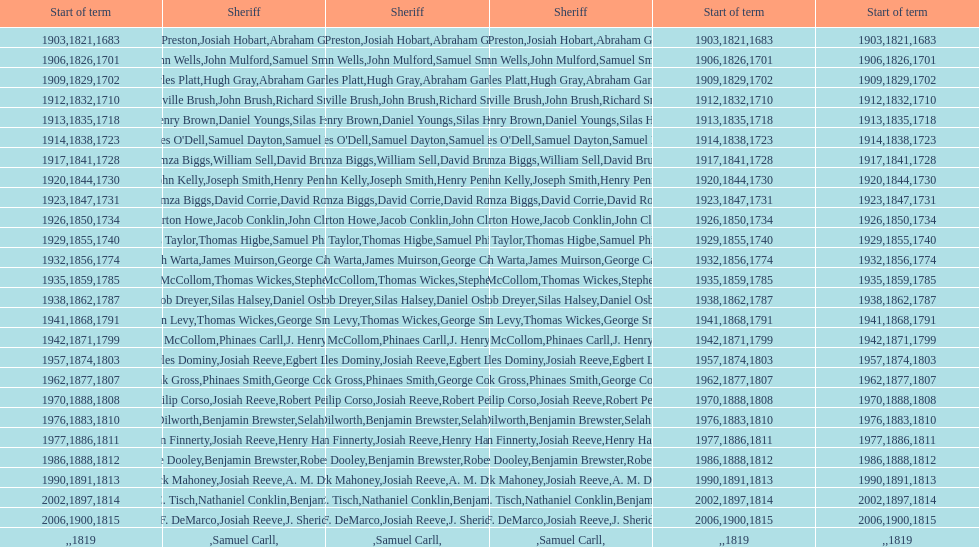Could you help me parse every detail presented in this table? {'header': ['Start of term', 'Sheriff', 'Sheriff', 'Sheriff', 'Start of term', 'Start of term'], 'rows': [['1903', 'Henry Preston', 'Josiah Hobart', 'Abraham Gardiner', '1821', '1683'], ['1906', 'John Wells', 'John Mulford', 'Samuel Smith', '1826', '1701'], ['1909', 'Charles Platt', 'Hugh Gray', 'Abraham Gardiner', '1829', '1702'], ['1912', 'Melville Brush', 'John Brush', 'Richard Smith', '1832', '1710'], ['1913', 'D. Henry Brown', 'Daniel Youngs', 'Silas Horton', '1835', '1718'], ['1914', "Charles O'Dell", 'Samuel Dayton', 'Samuel Miller', '1838', '1723'], ['1917', 'Amza Biggs', 'William Sell', 'David Brush', '1841', '1728'], ['1920', 'John Kelly', 'Joseph Smith', 'Henry Penny', '1844', '1730'], ['1923', 'Amza Biggs', 'David Corrie', 'David Rose', '1847', '1731'], ['1926', 'Burton Howe', 'Jacob Conklin', 'John Clark', '1850', '1734'], ['1929', 'Ellis Taylor', 'Thomas Higbe', 'Samuel Phillips', '1855', '1740'], ['1932', 'Joseph Warta', 'James Muirson', 'George Carman', '1856', '1774'], ['1935', 'William McCollom', 'Thomas Wickes', 'Stephen Wilson', '1859', '1785'], ['1938', 'Jacob Dreyer', 'Silas Halsey', 'Daniel Osborn', '1862', '1787'], ['1941', 'John Levy', 'Thomas Wickes', 'George Smith', '1868', '1791'], ['1942', 'William McCollom', 'Phinaes Carll', 'J. Henry Perkins', '1871', '1799'], ['1957', 'Charles Dominy', 'Josiah Reeve', 'Egbert Lewis', '1874', '1803'], ['1962', 'Frank Gross', 'Phinaes Smith', 'George Cooper', '1877', '1807'], ['1970', 'Philip Corso', 'Josiah Reeve', 'Robert Petty', '1888', '1808'], ['1976', 'Donald Dilworth', 'Benjamin Brewster', 'Selah Brewster', '1883', '1810'], ['1977', 'John Finnerty', 'Josiah Reeve', 'Henry Halsey', '1886', '1811'], ['1986', 'Eugene Dooley', 'Benjamin Brewster', 'Robert Petty', '1888', '1812'], ['1990', 'Patrick Mahoney', 'Josiah Reeve', 'A. M. Darling', '1891', '1813'], ['2002', 'Alfred C. Tisch', 'Nathaniel Conklin', 'Benjamin Wood', '1897', '1814'], ['2006', 'Vincent F. DeMarco', 'Josiah Reeve', 'J. Sheridan Wells', '1900', '1815'], ['', '', 'Samuel Carll', '', '', '1819']]} When did the inaugural term of the first sheriff begin? 1683. 